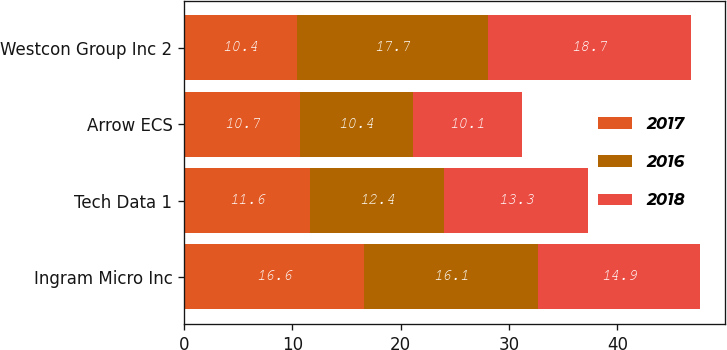Convert chart. <chart><loc_0><loc_0><loc_500><loc_500><stacked_bar_chart><ecel><fcel>Ingram Micro Inc<fcel>Tech Data 1<fcel>Arrow ECS<fcel>Westcon Group Inc 2<nl><fcel>2017<fcel>16.6<fcel>11.6<fcel>10.7<fcel>10.4<nl><fcel>2016<fcel>16.1<fcel>12.4<fcel>10.4<fcel>17.7<nl><fcel>2018<fcel>14.9<fcel>13.3<fcel>10.1<fcel>18.7<nl></chart> 